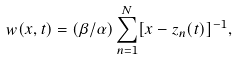Convert formula to latex. <formula><loc_0><loc_0><loc_500><loc_500>w ( x , t ) = ( \beta / \alpha ) \sum ^ { N } _ { n = 1 } [ x - z _ { n } ( t ) ] ^ { - 1 } ,</formula> 